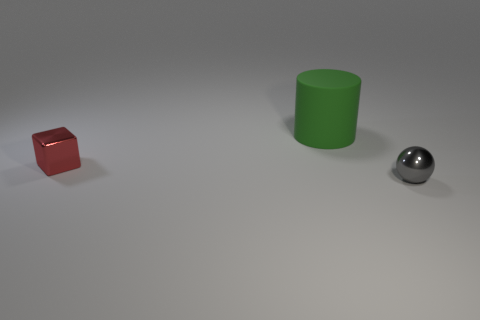Add 3 brown rubber blocks. How many objects exist? 6 Subtract all cubes. How many objects are left? 2 Subtract all big blue cubes. Subtract all small balls. How many objects are left? 2 Add 1 tiny red things. How many tiny red things are left? 2 Add 1 gray balls. How many gray balls exist? 2 Subtract 0 brown cylinders. How many objects are left? 3 